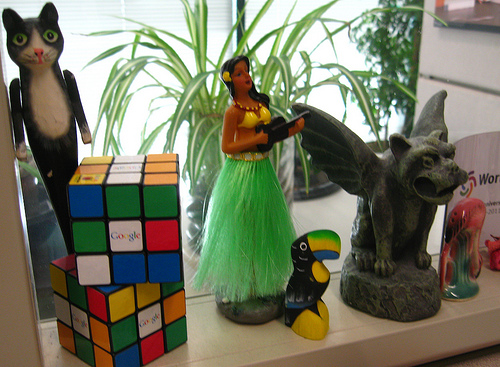<image>
Is there a cat on the cube? Yes. Looking at the image, I can see the cat is positioned on top of the cube, with the cube providing support. 